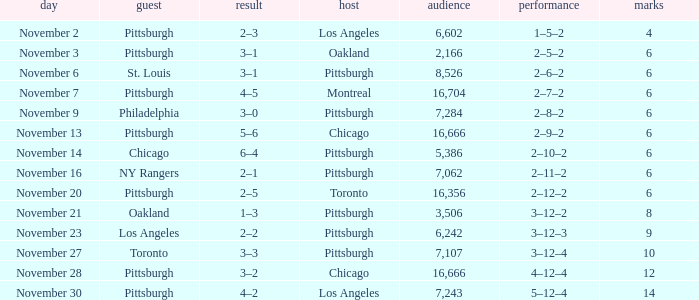What is the lowest amount of points of the game with toronto as the home team? 6.0. 